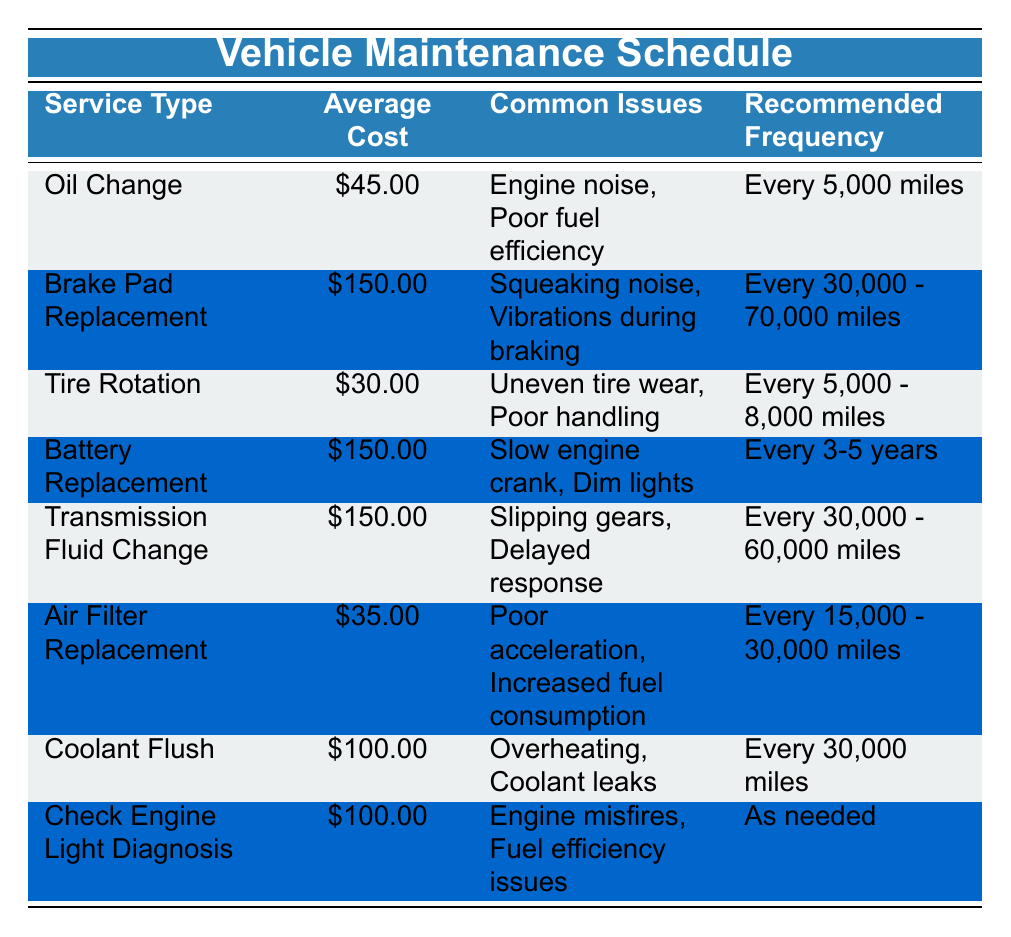What is the average cost of an Oil Change? The table states the average cost for an Oil Change is listed right next to the service type, which is $45.00.
Answer: 45.00 How often should you perform a Tire Rotation? The recommended frequency for Tire Rotation is found in the corresponding column and states it should be done every 5,000 - 8,000 miles.
Answer: Every 5,000 - 8,000 miles Is the average cost for a Brake Pad Replacement higher than $100? To answer this, we check the Average Cost for Brake Pad Replacement, which is listed as $150.00. Since $150.00 is greater than $100, the answer is yes.
Answer: Yes What are the common issues associated with Battery Replacement? The table provides a clear list of common issues for each service type; for Battery Replacement, they are Slow engine crank and Dim lights.
Answer: Slow engine crank, Dim lights Calculate the total average cost of changing the Oil, Tire Rotation, and Air Filter Replacement. The average costs for each service are $45.00 (Oil Change), $30.00 (Tire Rotation), and $35.00 (Air Filter Replacement). Adding these values gives a total of 45 + 30 + 35 = 110.
Answer: 110 Does the Check Engine Light Diagnosis have a recommended frequency for maintenance? The table states that Check Engine Light Diagnosis is performed "As needed," implying there is no specific frequency recommended.
Answer: No What service requires the longest recommended frequency between Brake Pad Replacement and Transmission Fluid Change? We check the recommended frequency for both services: Brake Pad Replacement is every 30,000 - 70,000 miles and Transmission Fluid Change is every 30,000 - 60,000 miles. The Brake Pad Replacement frequency goes up to 70,000 miles.
Answer: Brake Pad Replacement Which service type has the lowest average cost? By comparing the Average Costs for all service types in the table, Tire Rotation is listed as the least expensive with an average cost of $30.00.
Answer: Tire Rotation What common issue does a Coolant Flush address? The table lists that the common issues related to a Coolant Flush are Overheating and Coolant leaks, which are specifically mentioned next to this service type.
Answer: Overheating, Coolant leaks 